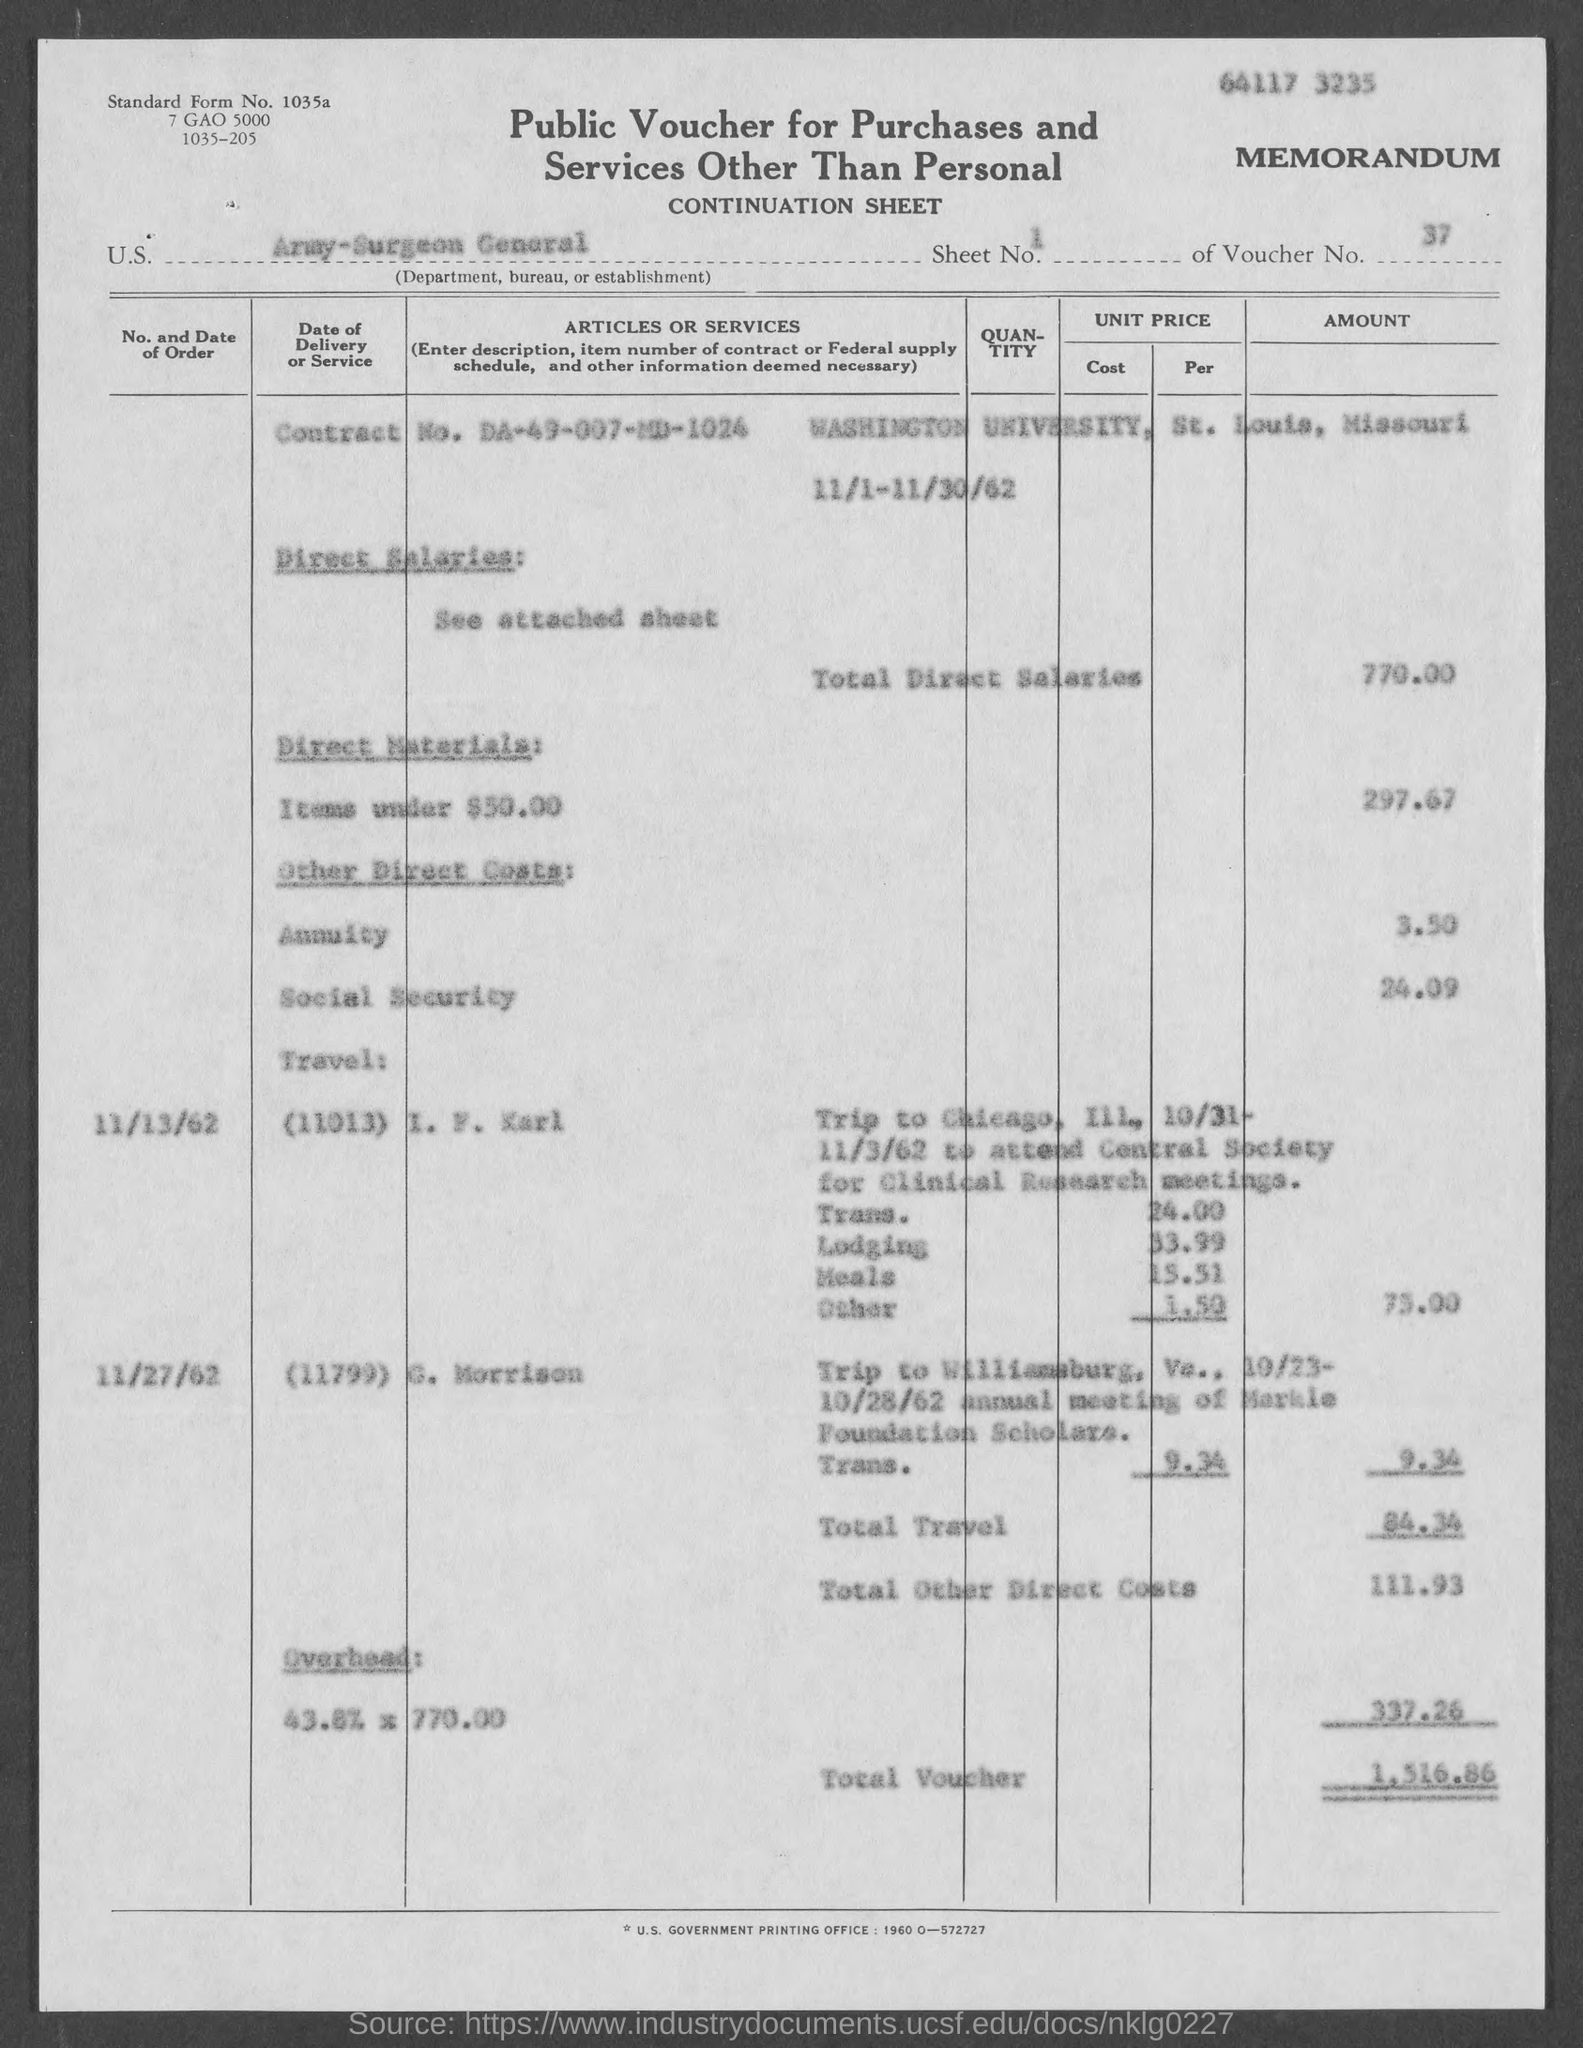What is the sheet no. mentioned in the given form ?
Your answer should be compact. 1. What is the voucher no. mentioned in the given form ?
Your answer should be very brief. 37. What is the contract no. mentioned in the given form ?
Make the answer very short. Da-49-007-md-1024. What is the name of the university mentioned in the given form ?
Keep it short and to the point. Washington university. What is the amount for total direct salaries mentioned in the given page ?
Your response must be concise. 770. What is the amount for direct materials as mentioned in the given form ?
Offer a very short reply. 297.67. What is the amount for annuity as mentioned in the given form ?
Offer a terse response. 3.50. What is the amount for social security as mentioned in the given form ?
Keep it short and to the point. 24.09. What is the amount for total travel as mentioned in the given form ?
Your answer should be very brief. 84.34. What is the amount for total other direct costs as mentioned in the given form ?
Make the answer very short. 111.93. What is the amount for overhead mentioned in the given form ?
Your response must be concise. 337.26. What is the amount of total voucher as mentioned in the given form ?
Offer a very short reply. 1,516.86. 